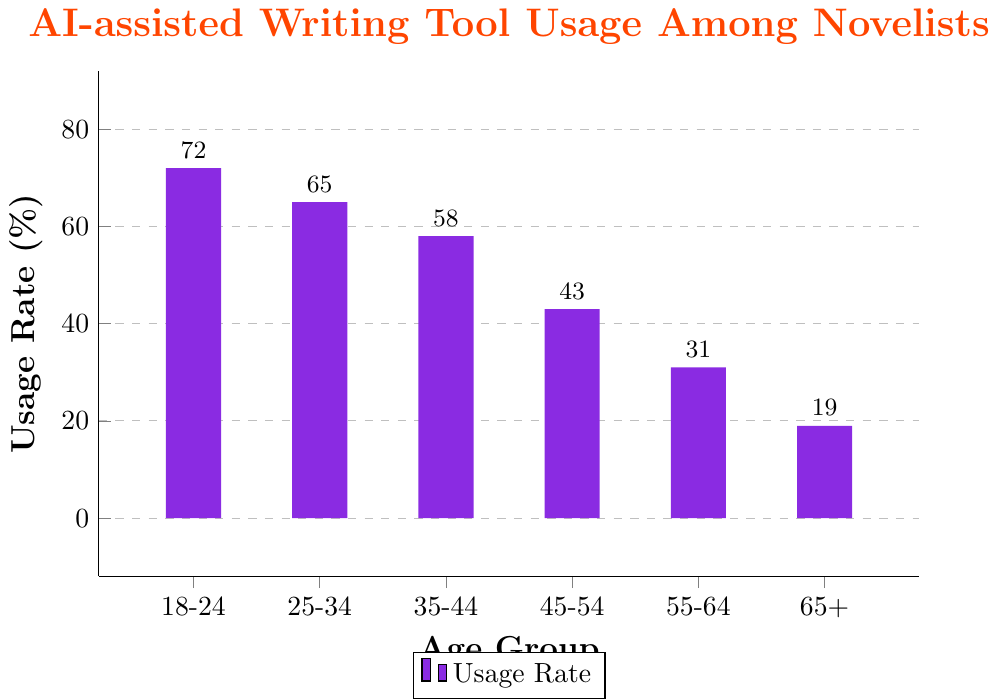What is the usage rate of AI-assisted writing tools for novelists aged 45-54? The bar corresponding to the age group 45-54 reaches up to the 43% mark.
Answer: 43% Which age group has the highest usage rate of AI-assisted writing tools? The bar for the 18-24 age group is the tallest, reaching 72%. This indicates it has the highest usage rate.
Answer: 18-24 How much higher is the usage rate for the 18-24 age group compared to the 65+ age group? The bar for the 18-24 age group is at 72% and the bar for the 65+ age group is at 19%. The difference is 72% - 19% = 53%.
Answer: 53% What is the average usage rate of AI-assisted writing tools across all age groups? Summing up the usage rates for all age groups: 72 + 65 + 58 + 43 + 31 + 19 = 288. There are 6 age groups, so the average is 288 / 6 = 48%.
Answer: 48% Which color represents the bars in the chart? The visual attribute shows that all the bars are colored in a specific shade that looks like purple.
Answer: purple Is the usage rate higher for the age group 35-44 or the age group 55-64? The bar for the age group 35-44 is at 58%, whereas the bar for the age group 55-64 is at 31%. Therefore, the usage rate is higher for the age group 35-44.
Answer: 35-44 What is the median usage rate among the given age groups? To find the median, list the usage rates in ascending order: 19, 31, 43, 58, 65, 72. The median is the middle value, so (43 + 58) / 2 = 50.5%.
Answer: 50.5% How much lower is the usage rate of AI-assisted writing tools for novelists aged 55-64 compared to novelists aged 25-34? The bar for the age group 55-64 is at 31% and the bar for the age group 25-34 is at 65%. The difference is 65% - 31% = 34%.
Answer: 34% What is the total usage rate of AI-assisted writing tools for all age groups combined? Adding up the usage rates: 72 + 65 + 58 + 43 + 31 + 19 = 288%.
Answer: 288% 